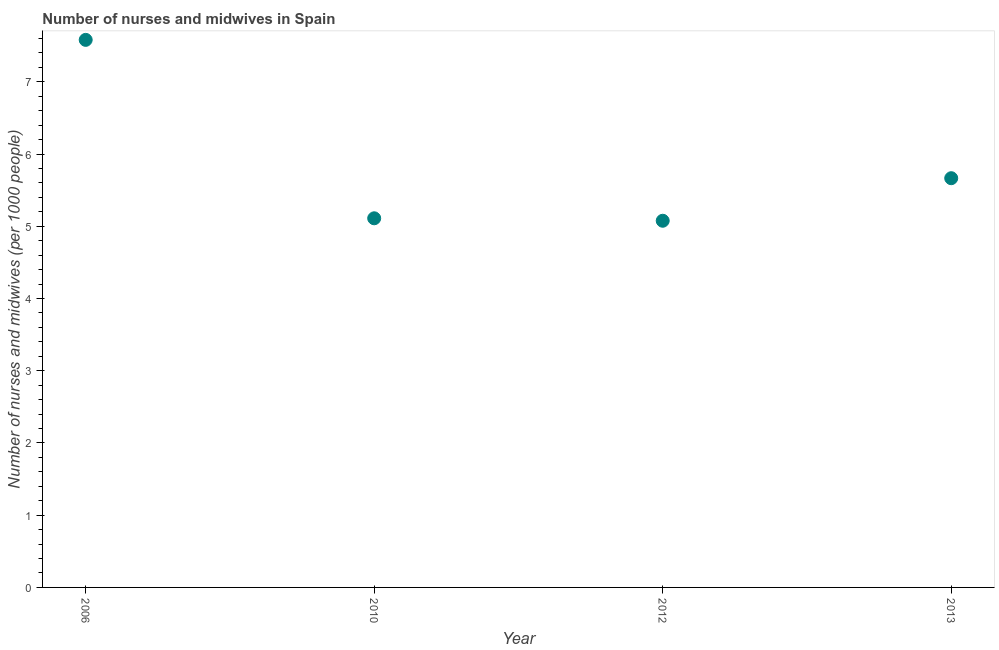What is the number of nurses and midwives in 2006?
Offer a terse response. 7.58. Across all years, what is the maximum number of nurses and midwives?
Provide a succinct answer. 7.58. Across all years, what is the minimum number of nurses and midwives?
Provide a succinct answer. 5.08. In which year was the number of nurses and midwives maximum?
Provide a short and direct response. 2006. In which year was the number of nurses and midwives minimum?
Provide a short and direct response. 2012. What is the sum of the number of nurses and midwives?
Your response must be concise. 23.43. What is the difference between the number of nurses and midwives in 2006 and 2013?
Make the answer very short. 1.92. What is the average number of nurses and midwives per year?
Ensure brevity in your answer.  5.86. What is the median number of nurses and midwives?
Keep it short and to the point. 5.39. Do a majority of the years between 2012 and 2010 (inclusive) have number of nurses and midwives greater than 4.8 ?
Provide a short and direct response. No. What is the ratio of the number of nurses and midwives in 2010 to that in 2013?
Provide a short and direct response. 0.9. Is the number of nurses and midwives in 2012 less than that in 2013?
Give a very brief answer. Yes. What is the difference between the highest and the second highest number of nurses and midwives?
Provide a short and direct response. 1.92. What is the difference between the highest and the lowest number of nurses and midwives?
Offer a very short reply. 2.5. In how many years, is the number of nurses and midwives greater than the average number of nurses and midwives taken over all years?
Make the answer very short. 1. Does the number of nurses and midwives monotonically increase over the years?
Provide a short and direct response. No. How many years are there in the graph?
Your answer should be very brief. 4. What is the difference between two consecutive major ticks on the Y-axis?
Give a very brief answer. 1. Does the graph contain grids?
Provide a short and direct response. No. What is the title of the graph?
Provide a succinct answer. Number of nurses and midwives in Spain. What is the label or title of the X-axis?
Offer a terse response. Year. What is the label or title of the Y-axis?
Provide a short and direct response. Number of nurses and midwives (per 1000 people). What is the Number of nurses and midwives (per 1000 people) in 2006?
Ensure brevity in your answer.  7.58. What is the Number of nurses and midwives (per 1000 people) in 2010?
Give a very brief answer. 5.11. What is the Number of nurses and midwives (per 1000 people) in 2012?
Make the answer very short. 5.08. What is the Number of nurses and midwives (per 1000 people) in 2013?
Offer a terse response. 5.67. What is the difference between the Number of nurses and midwives (per 1000 people) in 2006 and 2010?
Ensure brevity in your answer.  2.47. What is the difference between the Number of nurses and midwives (per 1000 people) in 2006 and 2012?
Make the answer very short. 2.5. What is the difference between the Number of nurses and midwives (per 1000 people) in 2006 and 2013?
Your response must be concise. 1.92. What is the difference between the Number of nurses and midwives (per 1000 people) in 2010 and 2012?
Provide a succinct answer. 0.03. What is the difference between the Number of nurses and midwives (per 1000 people) in 2010 and 2013?
Ensure brevity in your answer.  -0.56. What is the difference between the Number of nurses and midwives (per 1000 people) in 2012 and 2013?
Offer a terse response. -0.59. What is the ratio of the Number of nurses and midwives (per 1000 people) in 2006 to that in 2010?
Offer a very short reply. 1.48. What is the ratio of the Number of nurses and midwives (per 1000 people) in 2006 to that in 2012?
Offer a terse response. 1.49. What is the ratio of the Number of nurses and midwives (per 1000 people) in 2006 to that in 2013?
Ensure brevity in your answer.  1.34. What is the ratio of the Number of nurses and midwives (per 1000 people) in 2010 to that in 2012?
Make the answer very short. 1.01. What is the ratio of the Number of nurses and midwives (per 1000 people) in 2010 to that in 2013?
Your response must be concise. 0.9. What is the ratio of the Number of nurses and midwives (per 1000 people) in 2012 to that in 2013?
Offer a very short reply. 0.9. 